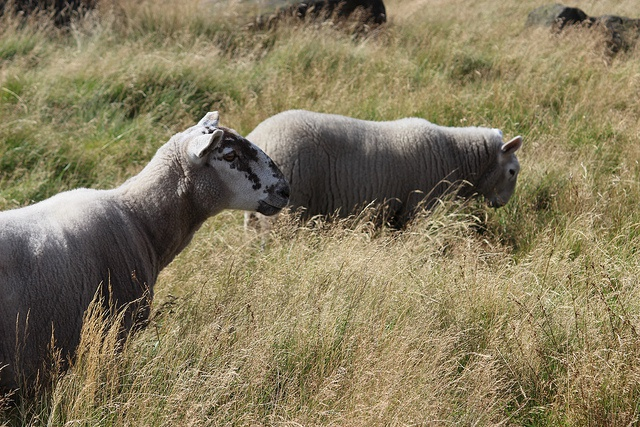Describe the objects in this image and their specific colors. I can see sheep in black, gray, lightgray, and darkgray tones and sheep in black, gray, darkgray, and lightgray tones in this image. 